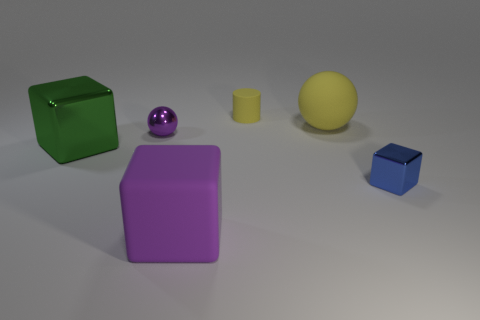Add 1 green cylinders. How many objects exist? 7 Subtract all large blocks. How many blocks are left? 1 Subtract all yellow spheres. How many spheres are left? 1 Subtract all cyan cubes. Subtract all brown spheres. How many cubes are left? 3 Subtract all gray spheres. How many cyan cubes are left? 0 Subtract all large metallic blocks. Subtract all yellow cylinders. How many objects are left? 4 Add 6 large things. How many large things are left? 9 Add 5 blue objects. How many blue objects exist? 6 Subtract 0 red spheres. How many objects are left? 6 Subtract all cylinders. How many objects are left? 5 